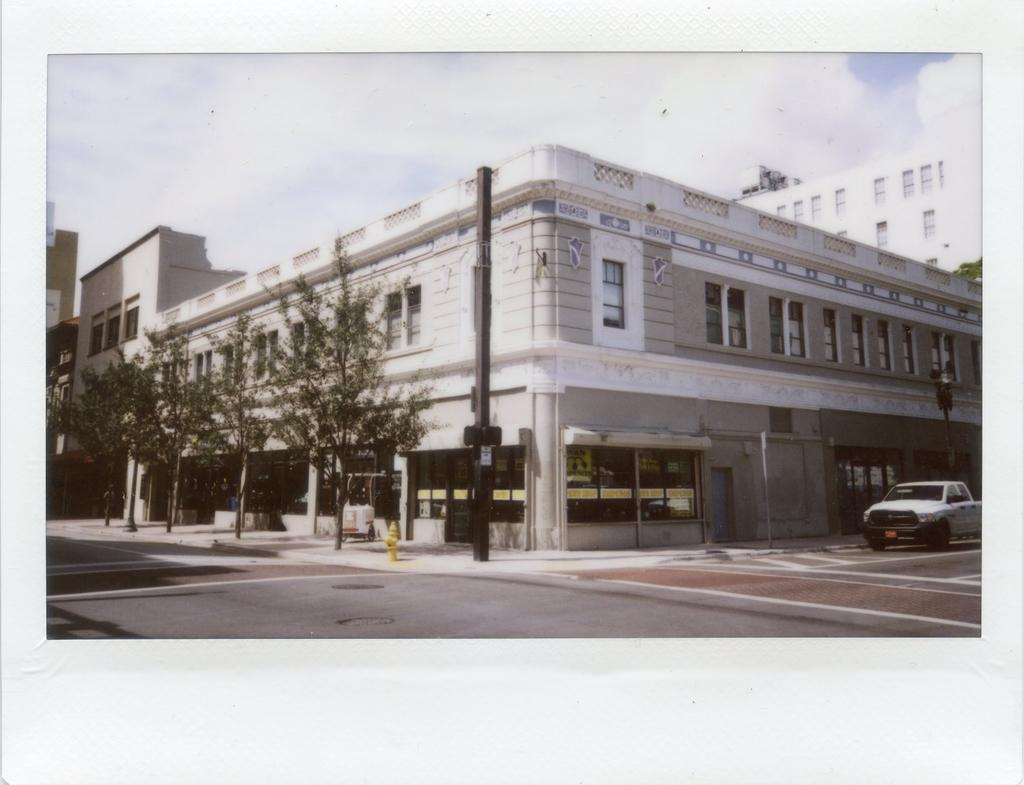What type of structures can be seen in the image? There are buildings with windows in the image. What other elements are present in the image? There are trees, poles, and a car on the road in the image. What is the condition of the sky in the image? The sky is visible in the image and appears cloudy. Can you see any clubs or locks on the trees in the image? There are no clubs or locks visible on the trees in the image. Are there any visible toes in the image? There are no visible toes in the image. 